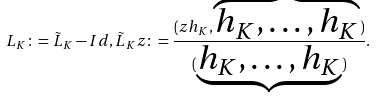Convert formula to latex. <formula><loc_0><loc_0><loc_500><loc_500>L _ { K } \colon = \tilde { L } _ { K } - I d , \tilde { L } _ { K } z \colon = \frac { ( z h _ { K } , \overbrace { h _ { K } , \dots , h _ { K } } ) } { ( \underbrace { h _ { K } , \dots , h _ { K } } ) } .</formula> 